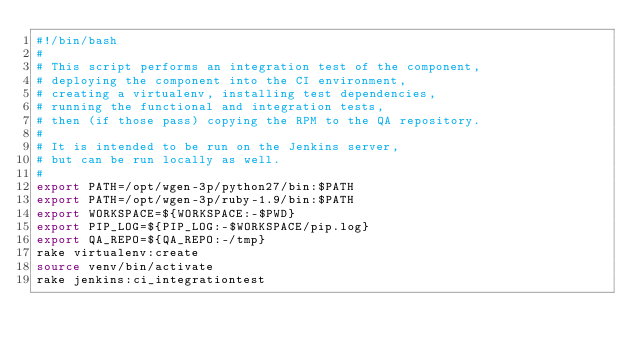Convert code to text. <code><loc_0><loc_0><loc_500><loc_500><_Bash_>#!/bin/bash
#
# This script performs an integration test of the component,
# deploying the component into the CI environment,
# creating a virtualenv, installing test dependencies,
# running the functional and integration tests,
# then (if those pass) copying the RPM to the QA repository.
#
# It is intended to be run on the Jenkins server,
# but can be run locally as well.
#
export PATH=/opt/wgen-3p/python27/bin:$PATH
export PATH=/opt/wgen-3p/ruby-1.9/bin:$PATH
export WORKSPACE=${WORKSPACE:-$PWD}
export PIP_LOG=${PIP_LOG:-$WORKSPACE/pip.log}
export QA_REPO=${QA_REPO:-/tmp}
rake virtualenv:create
source venv/bin/activate
rake jenkins:ci_integrationtest
</code> 